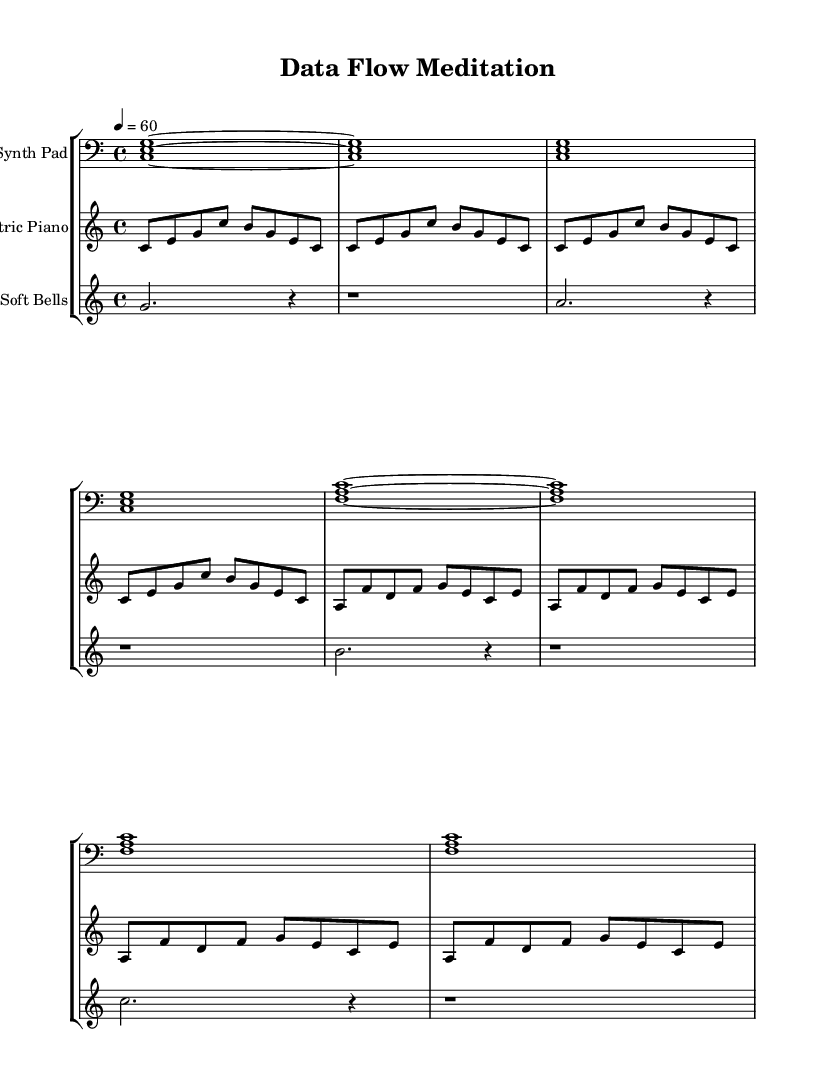What is the key signature of this music? The key signature is C major, which has no sharps or flats.
Answer: C major What is the time signature of this piece? The time signature is located at the beginning of the sheet music, where it shows a 4/4 symbol, indicating four beats per measure.
Answer: 4/4 What is the tempo marking for this composition? The tempo marking is indicated by "4 = 60," which means there are 60 beats per minute.
Answer: 60 How many staff instruments are included in this score? The score lists three distinct staves, each designated for a different instrument.
Answer: Three In which clef is the synth pad written? The clef used for the synth pad is the bass clef, as indicated at the beginning of its staff.
Answer: Bass What is the rhythmic value of the first measure of the electric piano part? The first measure contains four eighth notes, which are counted as one beat each in a 4/4 time signature.
Answer: Four eighth notes How many total notes are played in the first phrase of the soft bells part? By counting the notes in the first phrase, you see that there are four distinct notes played before the rest.
Answer: Four 